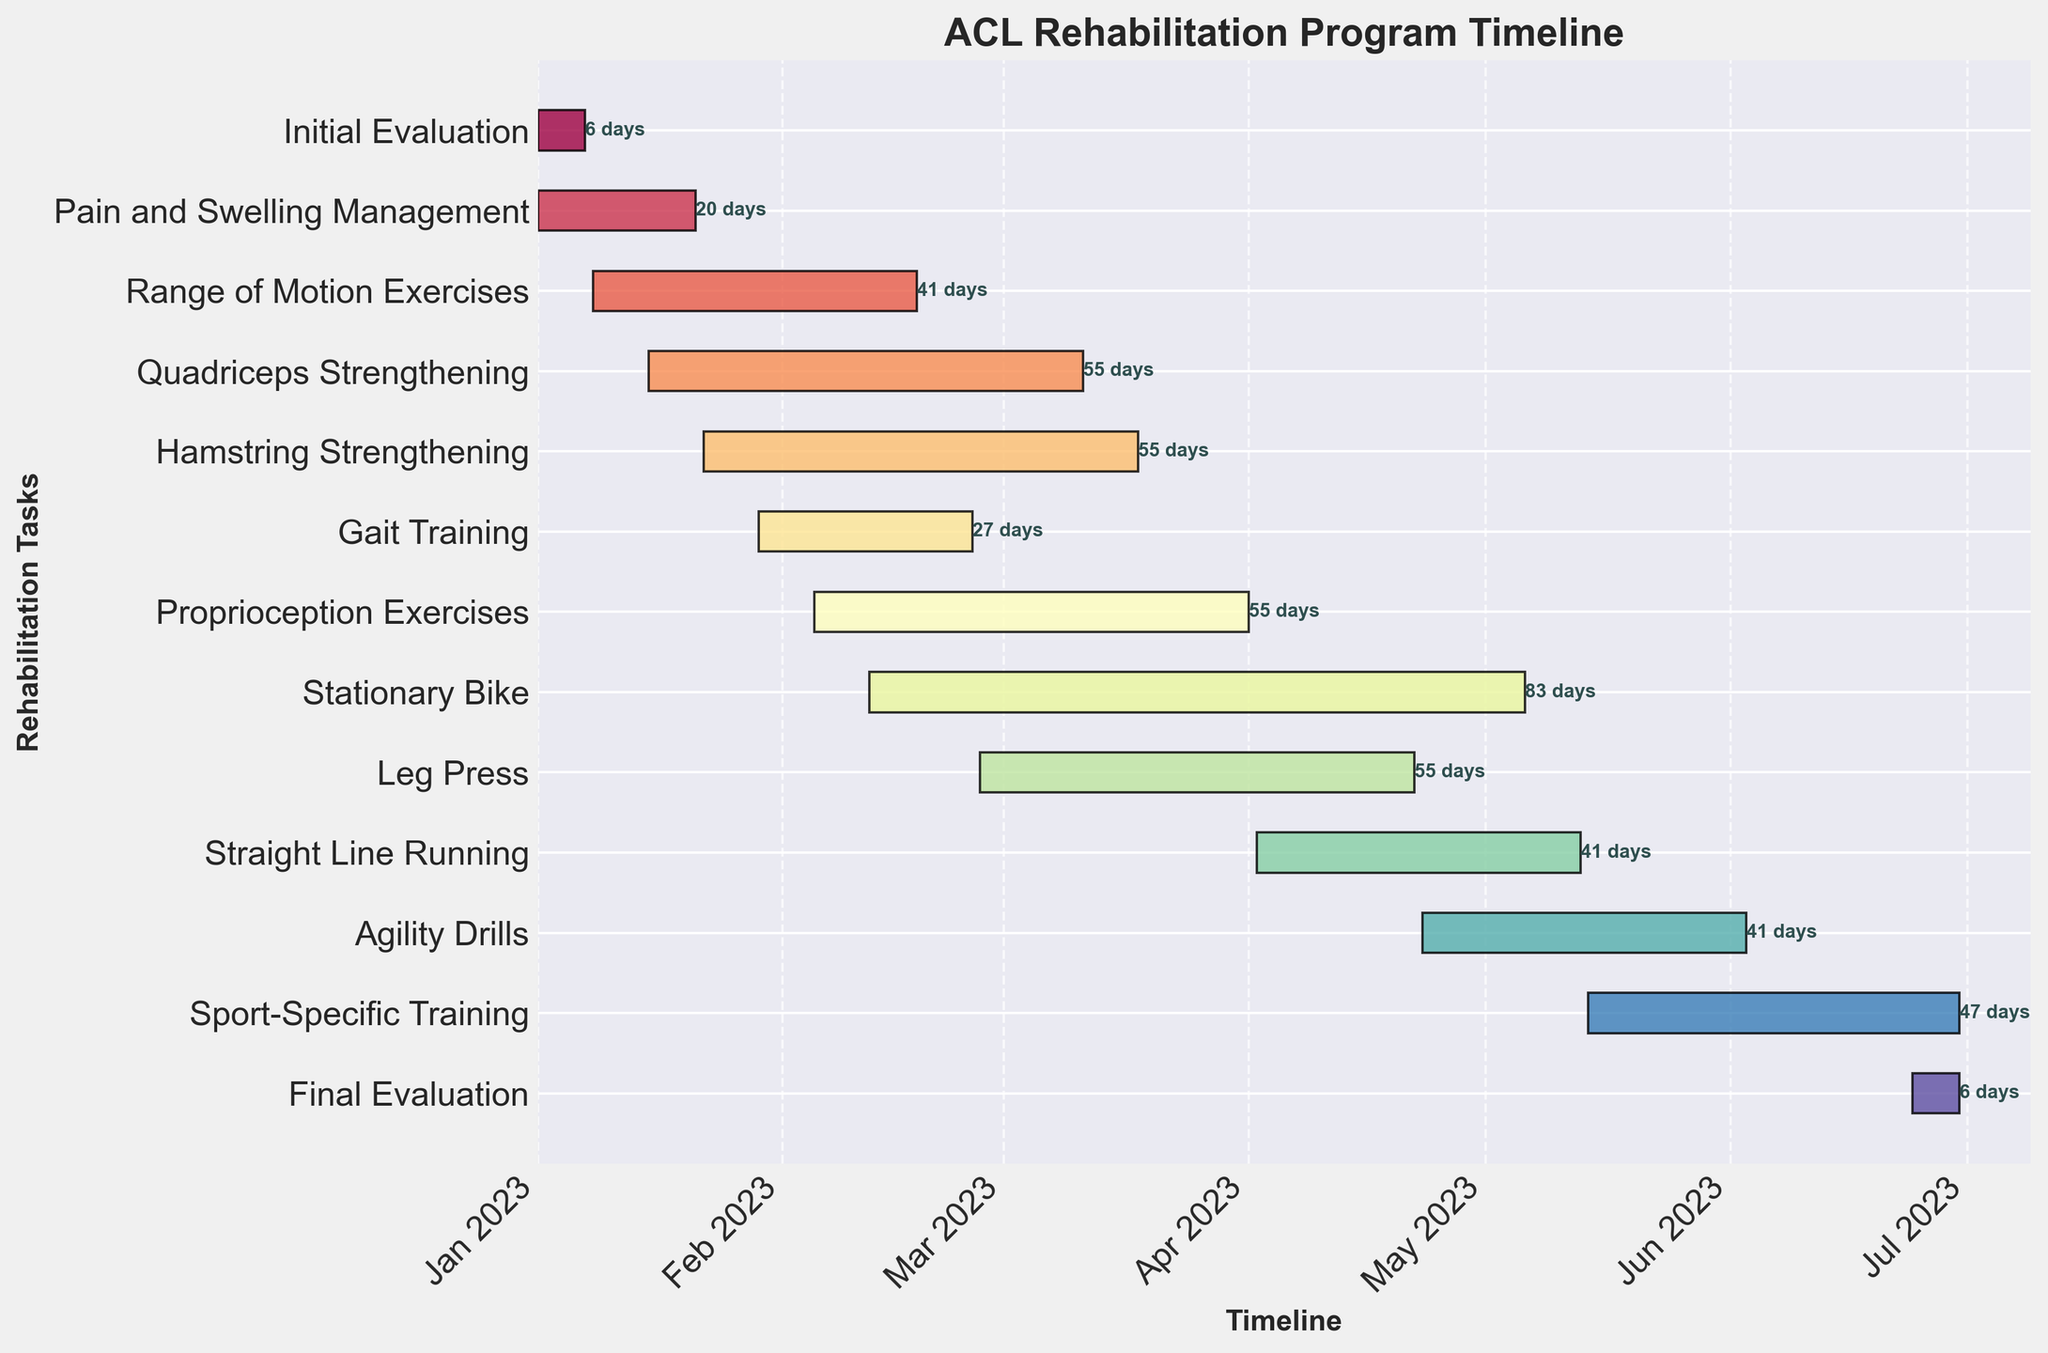What is the title of the chart? The title of the chart is prominently displayed at the top and provides a summary of the purpose of the chart. It reads: "ACL Rehabilitation Program Timeline."
Answer: ACL Rehabilitation Program Timeline How long does the Initial Evaluation phase last? By looking at the bar corresponding to the Initial Evaluation task, we can note the start and end dates. The bar starts on January 1, 2023, and ends on January 7, 2023. This results in a duration of 7 days.
Answer: 7 days How many days are dedicated to Pain and Swelling Management? The Pain and Swelling Management task starts on January 1, 2023, and ends on January 21, 2023. By subtracting the start date from the end date, we get 21 days.
Answer: 21 days Which task starts in April and what is its duration? By checking the start dates, we see that Straight Line Running starts on April 2, 2023. The duration is indicated on the bar as 42 days.
Answer: Straight Line Running with a duration of 42 days What is the longest task in the program and how long does it last? By comparing the lengths of all the bars, we see that Sport-Specific Training has the longest bar. It starts on May 14, 2023, and ends on June 30, 2023, lasting 48 days.
Answer: Sport-Specific Training, 48 days How many tasks are scheduled to start in January? Observing the start dates, we see that the following tasks start in January: Initial Evaluation, Pain and Swelling Management, Range of Motion Exercises, Quadriceps Strengthening, Hamstring Strengthening, and Gait Training. This gives us a count of 6 tasks.
Answer: 6 During which months does Proprioception Exercises take place? The bar for Proprioception Exercises starts on February 5, 2023, and ends on April 1, 2023. Thus, it spans three months: February, March, and part of April.
Answer: February, March, April Which task overlaps with Quadriceps Strengthening and for how many days? Hamstring Strengthening overlaps with Quadriceps Strengthening. To find the overlap period: Quadriceps Strengthening is from January 15 to March 11 and Hamstring Strengthening is from January 22 to March 18. The common period is from January 22 to March 11, totaling 48 days.
Answer: Hamstring Strengthening, 48 days Which tasks are included in the final month (June) of the program? According to the start and end dates, the tasks included in June are Agility Drills (ending on June 3), Sport-Specific Training (ends June 30), and Final Evaluation (June 24 - June 30).
Answer: Agility Drills, Sport-Specific Training, Final Evaluation 